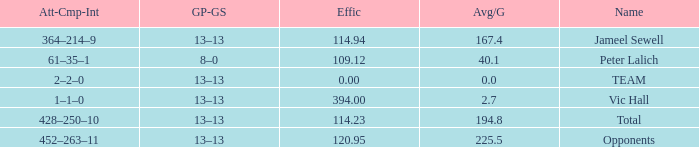Avg/G that has a Att-Cmp-Int of 1–1–0, and an Effic larger than 394 is what total? 0.0. Can you give me this table as a dict? {'header': ['Att-Cmp-Int', 'GP-GS', 'Effic', 'Avg/G', 'Name'], 'rows': [['364–214–9', '13–13', '114.94', '167.4', 'Jameel Sewell'], ['61–35–1', '8–0', '109.12', '40.1', 'Peter Lalich'], ['2–2–0', '13–13', '0.00', '0.0', 'TEAM'], ['1–1–0', '13–13', '394.00', '2.7', 'Vic Hall'], ['428–250–10', '13–13', '114.23', '194.8', 'Total'], ['452–263–11', '13–13', '120.95', '225.5', 'Opponents']]} 